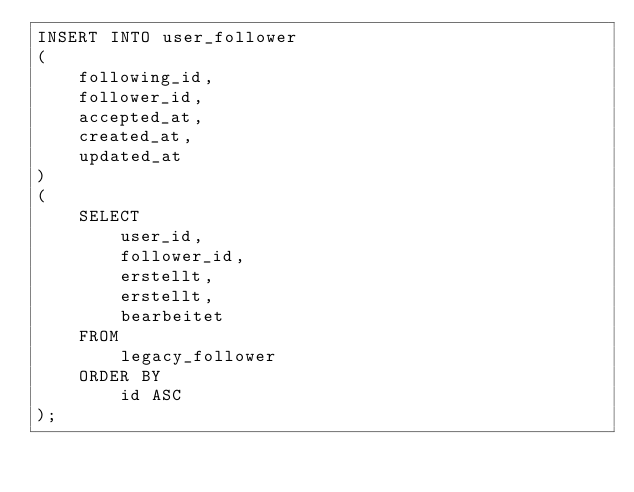Convert code to text. <code><loc_0><loc_0><loc_500><loc_500><_SQL_>INSERT INTO user_follower
(
    following_id,
    follower_id,
    accepted_at,
    created_at,
    updated_at
)
(
    SELECT
        user_id,
        follower_id,
        erstellt,
        erstellt,
        bearbeitet
    FROM
        legacy_follower
    ORDER BY
        id ASC
);</code> 